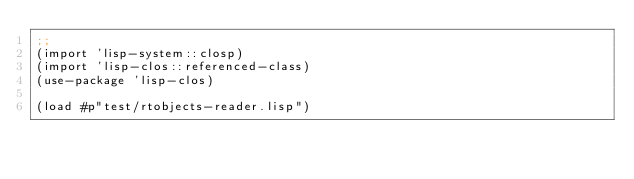<code> <loc_0><loc_0><loc_500><loc_500><_Lisp_>;;
(import 'lisp-system::closp)
(import 'lisp-clos::referenced-class)
(use-package 'lisp-clos)

(load #p"test/rtobjects-reader.lisp")</code> 